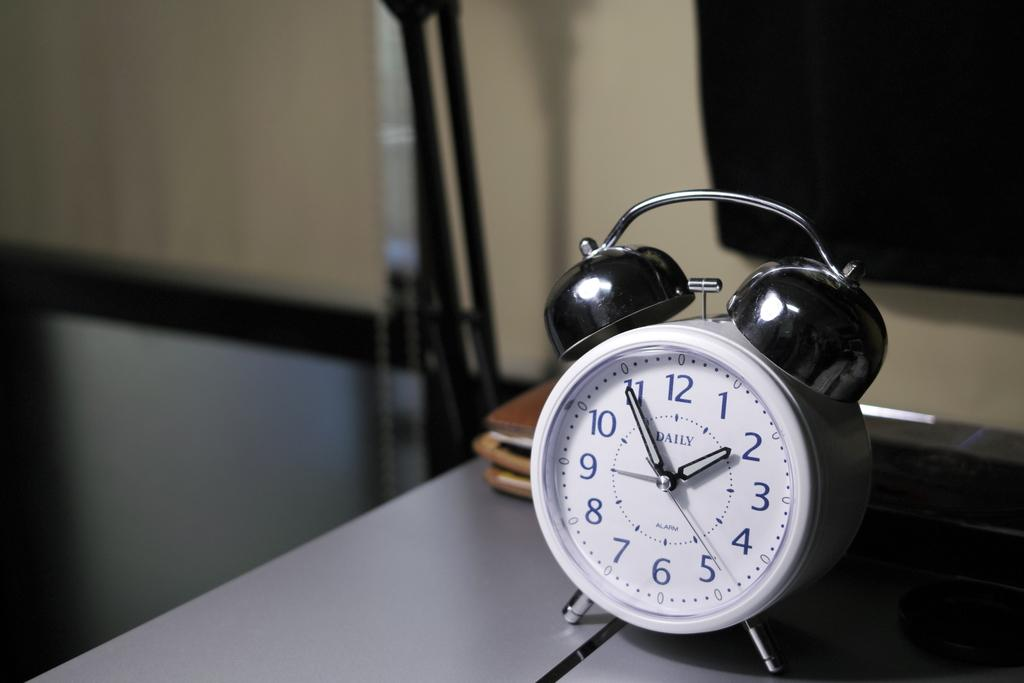Provide a one-sentence caption for the provided image. A silver alarm clock sitting on a table showing the time as 2 o'clock. 